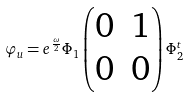<formula> <loc_0><loc_0><loc_500><loc_500>\varphi _ { u } = e ^ { \frac { \omega } { 2 } } \Phi _ { 1 } \begin{pmatrix} 0 & 1 \\ 0 & 0 \end{pmatrix} \Phi _ { 2 } ^ { t }</formula> 